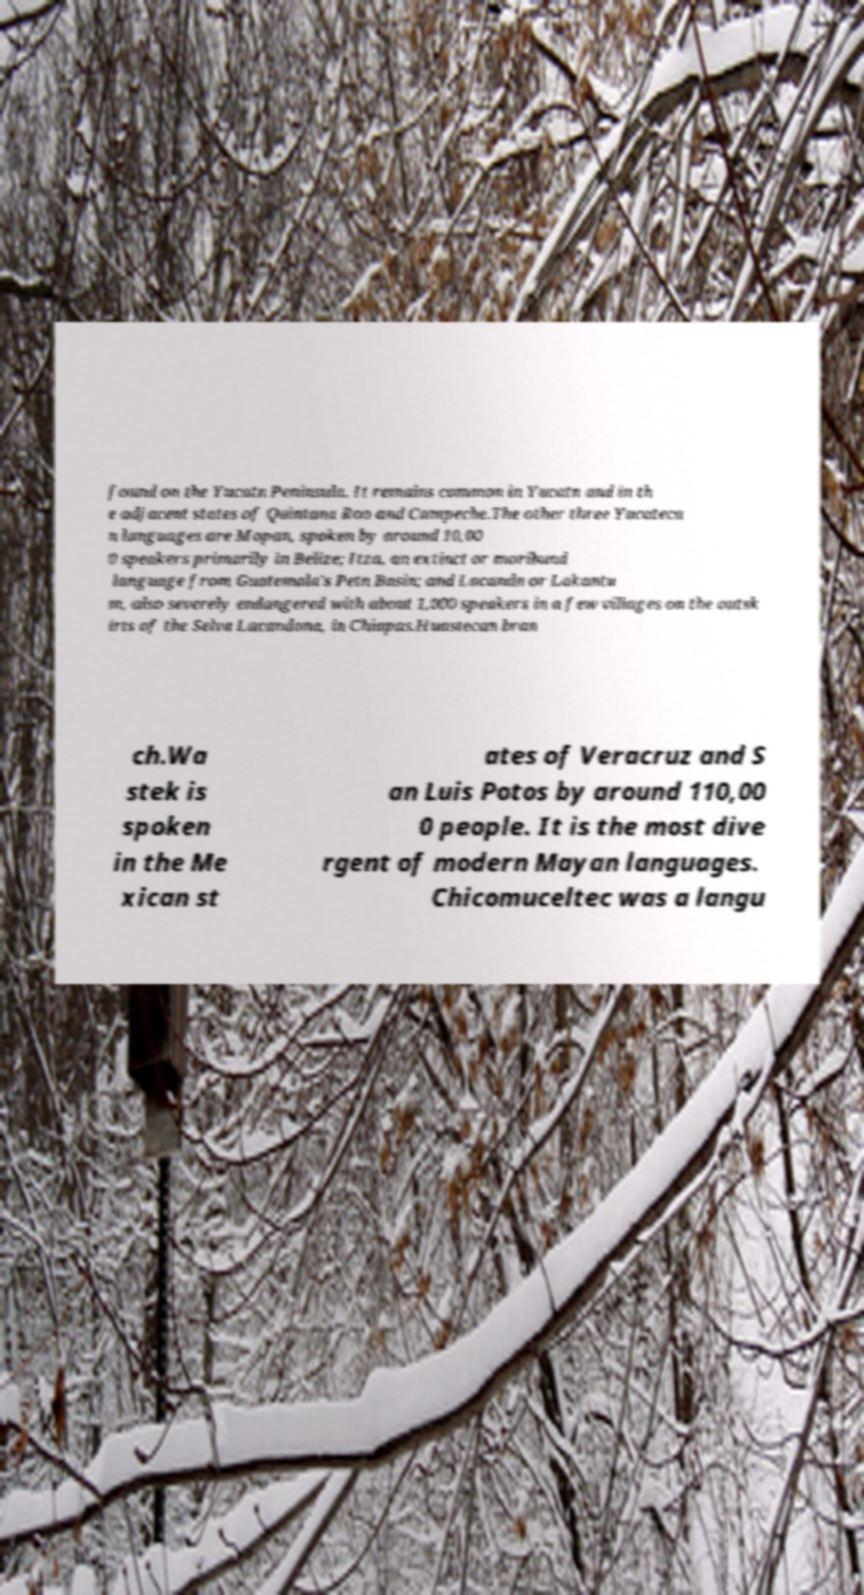I need the written content from this picture converted into text. Can you do that? found on the Yucatn Peninsula. It remains common in Yucatn and in th e adjacent states of Quintana Roo and Campeche.The other three Yucateca n languages are Mopan, spoken by around 10,00 0 speakers primarily in Belize; Itza, an extinct or moribund language from Guatemala's Petn Basin; and Lacandn or Lakantu m, also severely endangered with about 1,000 speakers in a few villages on the outsk irts of the Selva Lacandona, in Chiapas.Huastecan bran ch.Wa stek is spoken in the Me xican st ates of Veracruz and S an Luis Potos by around 110,00 0 people. It is the most dive rgent of modern Mayan languages. Chicomuceltec was a langu 